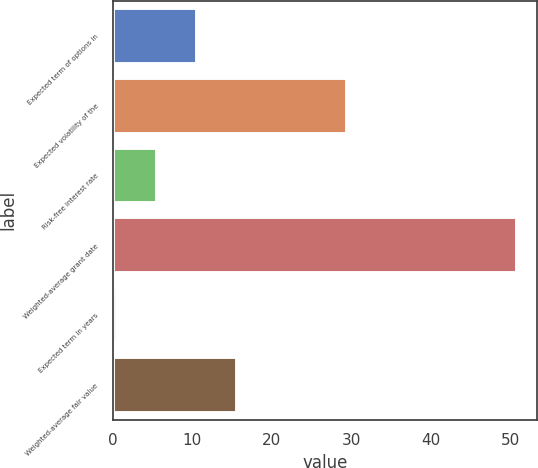<chart> <loc_0><loc_0><loc_500><loc_500><bar_chart><fcel>Expected term of options in<fcel>Expected volatility of the<fcel>Risk-free interest rate<fcel>Weighted-average grant date<fcel>Expected term in years<fcel>Weighted-average fair value<nl><fcel>10.56<fcel>29.4<fcel>5.53<fcel>50.84<fcel>0.5<fcel>15.59<nl></chart> 